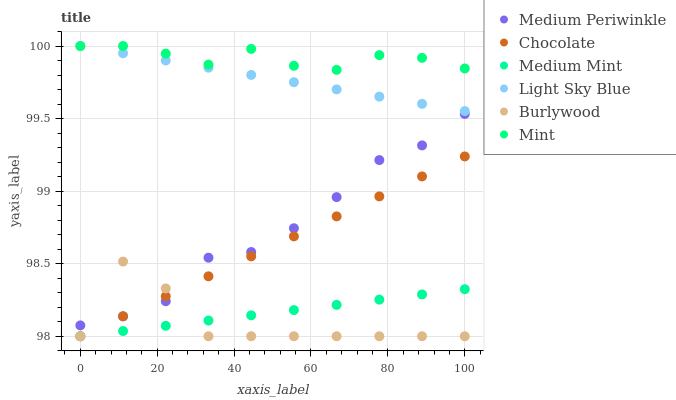Does Burlywood have the minimum area under the curve?
Answer yes or no. Yes. Does Mint have the maximum area under the curve?
Answer yes or no. Yes. Does Medium Periwinkle have the minimum area under the curve?
Answer yes or no. No. Does Medium Periwinkle have the maximum area under the curve?
Answer yes or no. No. Is Chocolate the smoothest?
Answer yes or no. Yes. Is Burlywood the roughest?
Answer yes or no. Yes. Is Medium Periwinkle the smoothest?
Answer yes or no. No. Is Medium Periwinkle the roughest?
Answer yes or no. No. Does Medium Mint have the lowest value?
Answer yes or no. Yes. Does Medium Periwinkle have the lowest value?
Answer yes or no. No. Does Mint have the highest value?
Answer yes or no. Yes. Does Burlywood have the highest value?
Answer yes or no. No. Is Chocolate less than Mint?
Answer yes or no. Yes. Is Medium Periwinkle greater than Medium Mint?
Answer yes or no. Yes. Does Chocolate intersect Medium Periwinkle?
Answer yes or no. Yes. Is Chocolate less than Medium Periwinkle?
Answer yes or no. No. Is Chocolate greater than Medium Periwinkle?
Answer yes or no. No. Does Chocolate intersect Mint?
Answer yes or no. No. 